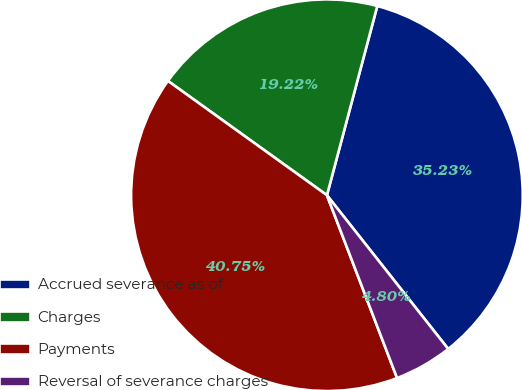<chart> <loc_0><loc_0><loc_500><loc_500><pie_chart><fcel>Accrued severance as of<fcel>Charges<fcel>Payments<fcel>Reversal of severance charges<nl><fcel>35.23%<fcel>19.22%<fcel>40.75%<fcel>4.8%<nl></chart> 